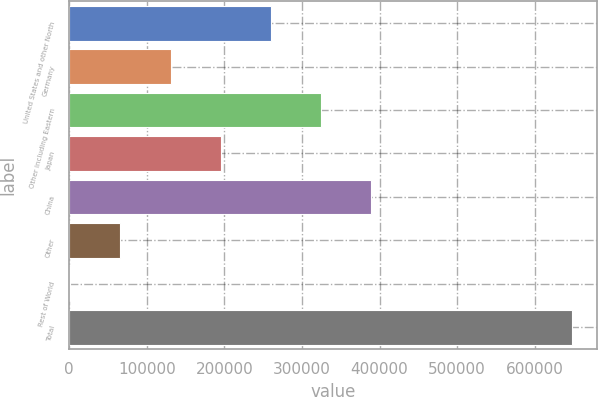Convert chart. <chart><loc_0><loc_0><loc_500><loc_500><bar_chart><fcel>United States and other North<fcel>Germany<fcel>Other including Eastern<fcel>Japan<fcel>China<fcel>Other<fcel>Rest of World<fcel>Total<nl><fcel>259941<fcel>130576<fcel>324623<fcel>195259<fcel>389305<fcel>65894.2<fcel>1212<fcel>648034<nl></chart> 